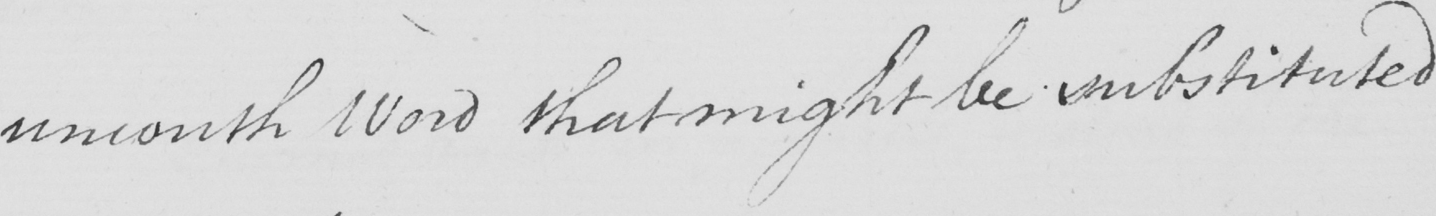Please transcribe the handwritten text in this image. uncouth Word that might be substituted 